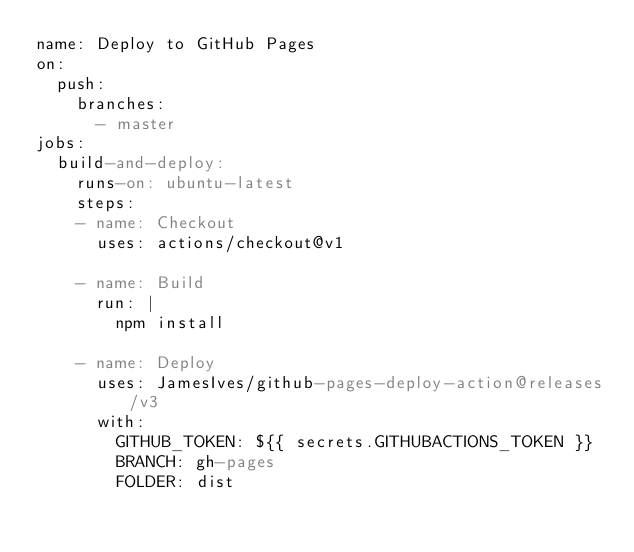Convert code to text. <code><loc_0><loc_0><loc_500><loc_500><_YAML_>name: Deploy to GitHub Pages
on:
  push:
    branches:
      - master
jobs:
  build-and-deploy:
    runs-on: ubuntu-latest
    steps:
    - name: Checkout
      uses: actions/checkout@v1

    - name: Build
      run: |
        npm install

    - name: Deploy
      uses: JamesIves/github-pages-deploy-action@releases/v3
      with:
        GITHUB_TOKEN: ${{ secrets.GITHUBACTIONS_TOKEN }}
        BRANCH: gh-pages
        FOLDER: dist
</code> 